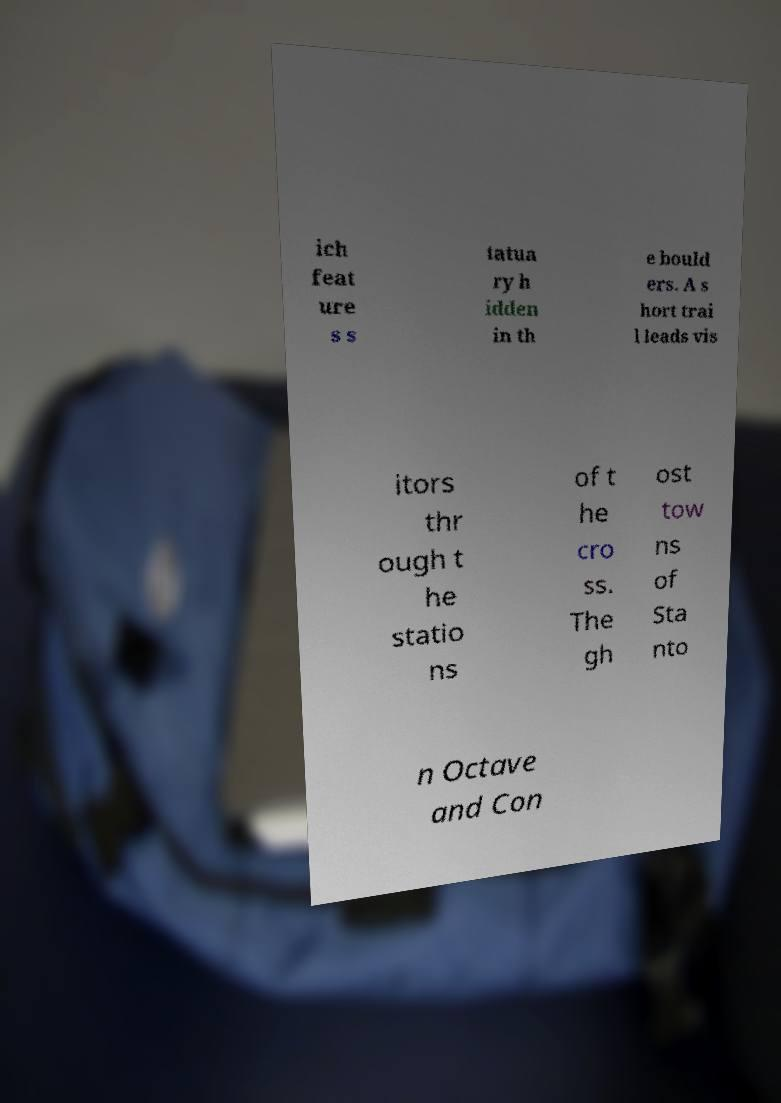I need the written content from this picture converted into text. Can you do that? ich feat ure s s tatua ry h idden in th e bould ers. A s hort trai l leads vis itors thr ough t he statio ns of t he cro ss. The gh ost tow ns of Sta nto n Octave and Con 